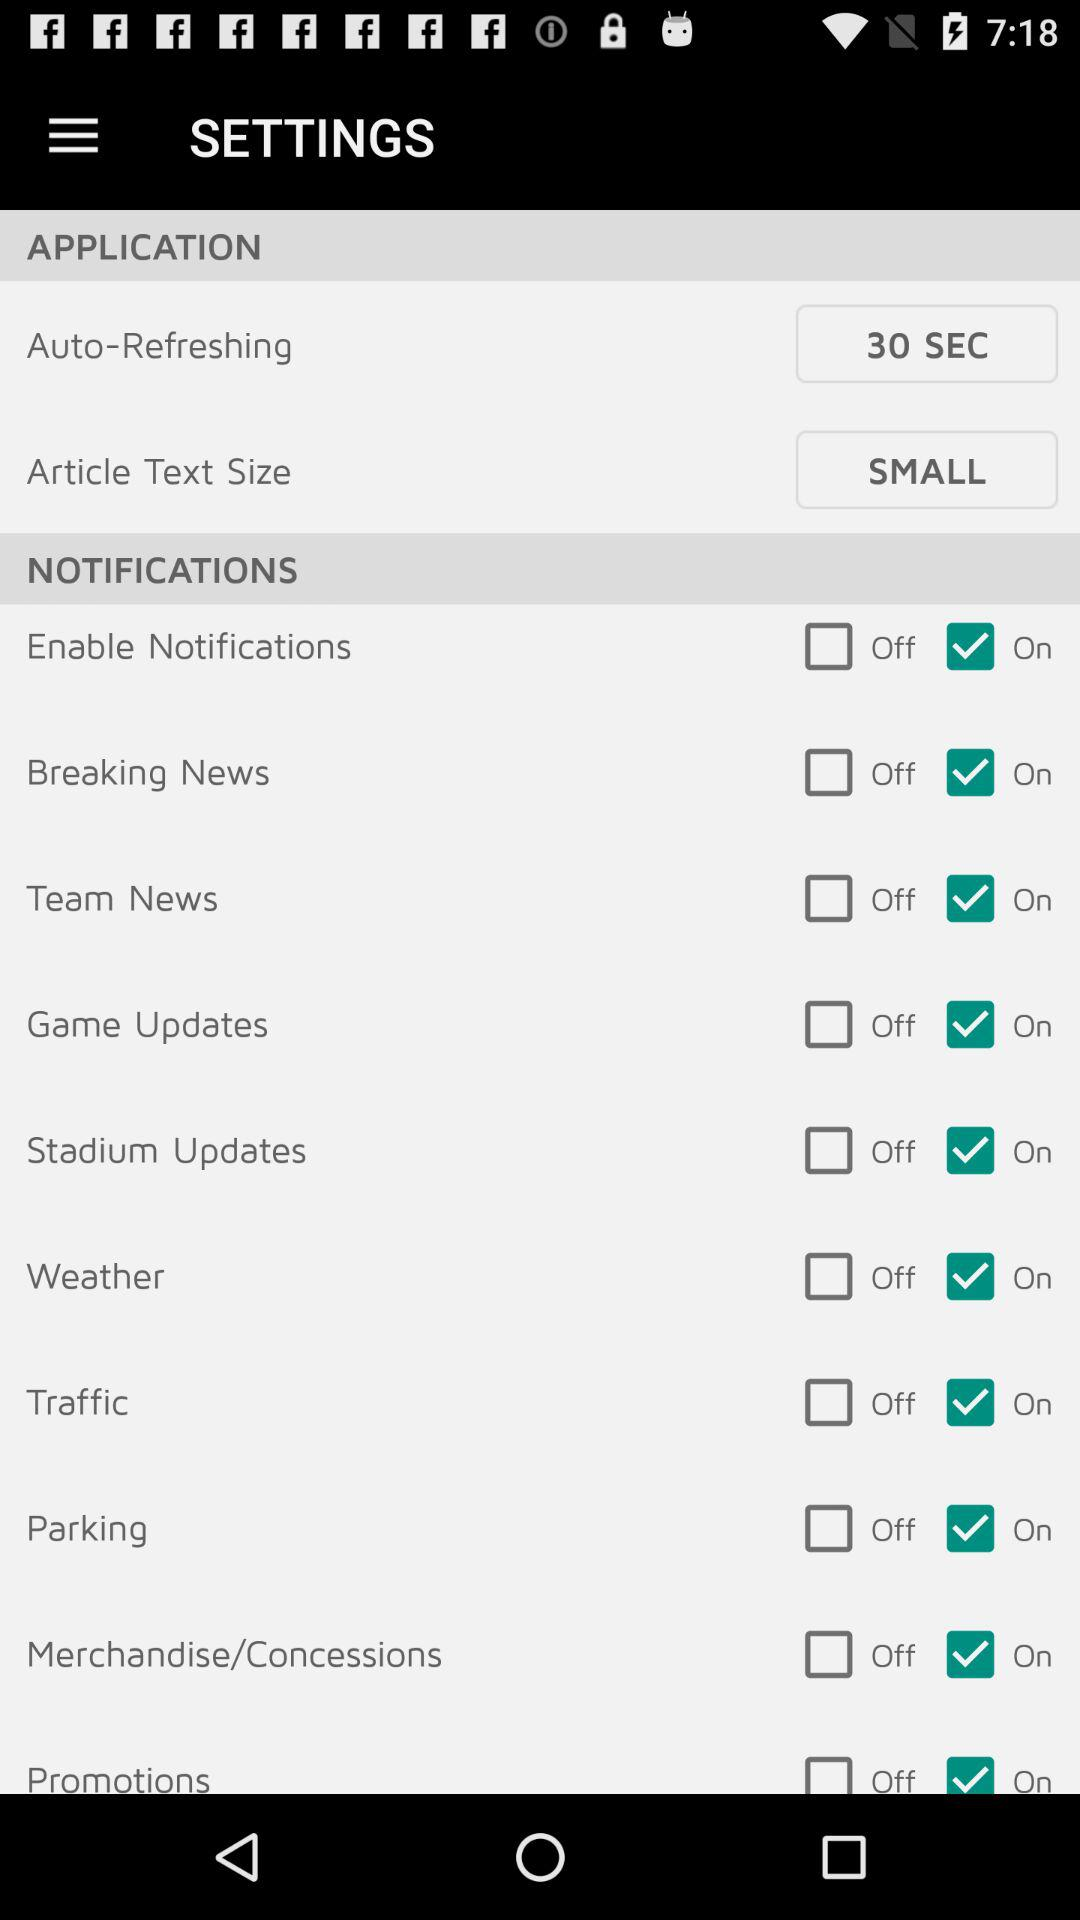What's the "Article Text Size"? The article text size is "SMALL". 